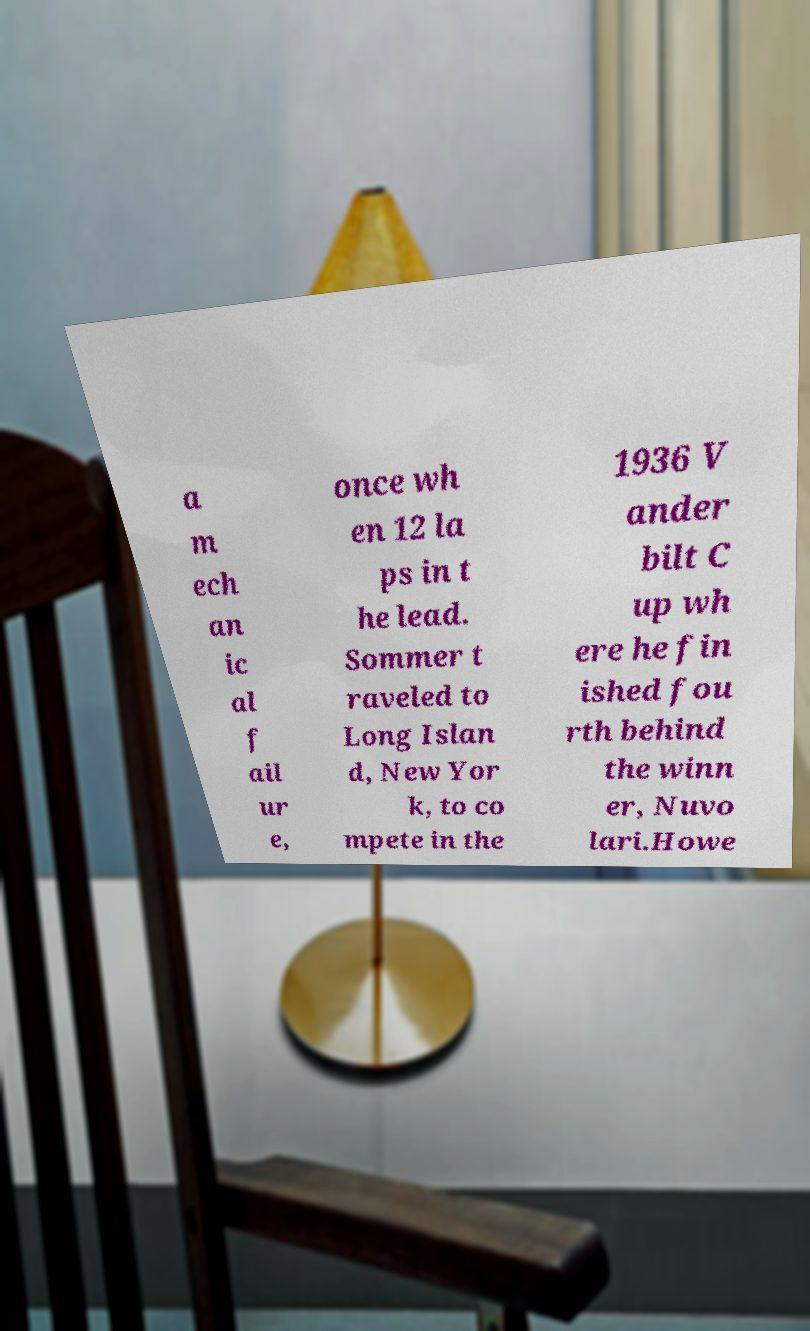What messages or text are displayed in this image? I need them in a readable, typed format. a m ech an ic al f ail ur e, once wh en 12 la ps in t he lead. Sommer t raveled to Long Islan d, New Yor k, to co mpete in the 1936 V ander bilt C up wh ere he fin ished fou rth behind the winn er, Nuvo lari.Howe 